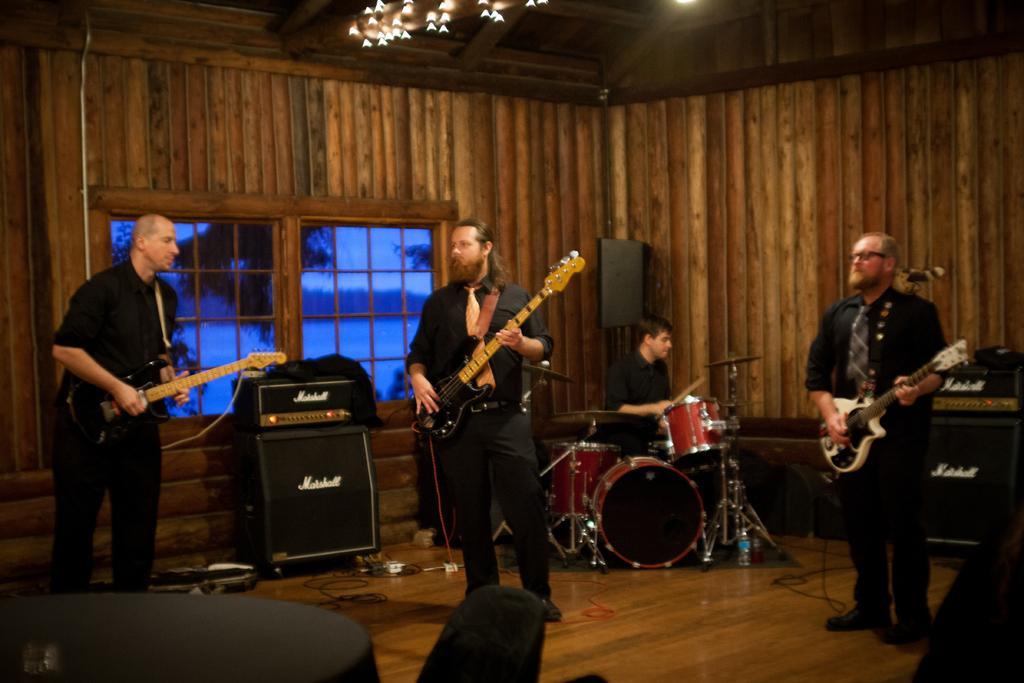Can you describe this image briefly? In this picture we can see three people standing on the floor, they are holding guitars, here we can see a table, glass, chair and in the background we can see musical drums, speaker, person, wall, windows, lights and some objects. 